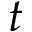Convert formula to latex. <formula><loc_0><loc_0><loc_500><loc_500>t</formula> 